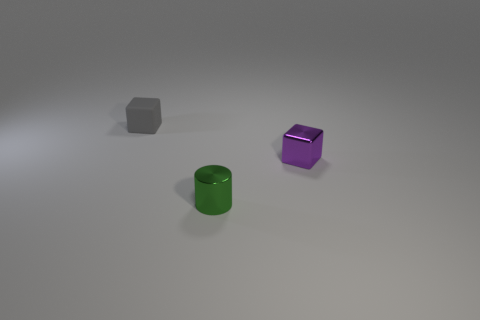How big is the cube that is to the left of the thing that is in front of the purple metallic object?
Ensure brevity in your answer.  Small. What is the size of the shiny object that is left of the metal block?
Your answer should be very brief. Small. Is the number of tiny gray matte blocks in front of the small gray matte object less than the number of gray things that are on the left side of the purple block?
Give a very brief answer. Yes. The tiny rubber thing is what color?
Your answer should be very brief. Gray. Is there a cylinder that has the same color as the small matte object?
Ensure brevity in your answer.  No. What is the shape of the object that is behind the cube that is right of the object behind the tiny purple shiny block?
Offer a terse response. Cube. What material is the cube that is on the right side of the gray rubber cube?
Your answer should be very brief. Metal. There is a shiny object that is behind the tiny shiny object to the left of the metallic thing to the right of the tiny green shiny cylinder; what size is it?
Provide a succinct answer. Small. Do the green shiny thing and the block that is to the right of the tiny gray object have the same size?
Give a very brief answer. Yes. The block that is on the right side of the small gray matte block is what color?
Your response must be concise. Purple. 